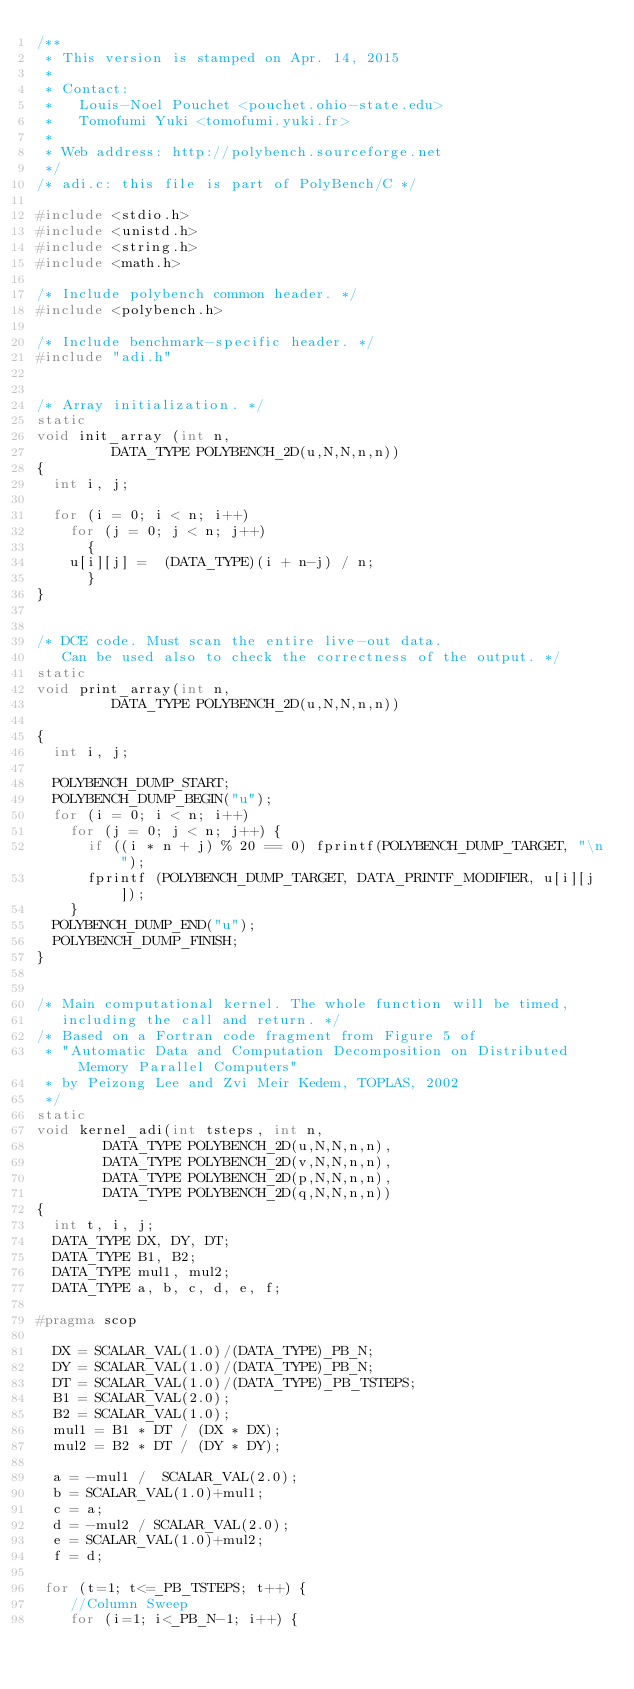Convert code to text. <code><loc_0><loc_0><loc_500><loc_500><_C_>/**
 * This version is stamped on Apr. 14, 2015
 *
 * Contact:
 *   Louis-Noel Pouchet <pouchet.ohio-state.edu>
 *   Tomofumi Yuki <tomofumi.yuki.fr>
 *
 * Web address: http://polybench.sourceforge.net
 */
/* adi.c: this file is part of PolyBench/C */

#include <stdio.h>
#include <unistd.h>
#include <string.h>
#include <math.h>

/* Include polybench common header. */
#include <polybench.h>

/* Include benchmark-specific header. */
#include "adi.h"


/* Array initialization. */
static
void init_array (int n,
		 DATA_TYPE POLYBENCH_2D(u,N,N,n,n))
{
  int i, j;

  for (i = 0; i < n; i++)
    for (j = 0; j < n; j++)
      {
	u[i][j] =  (DATA_TYPE)(i + n-j) / n;
      }
}


/* DCE code. Must scan the entire live-out data.
   Can be used also to check the correctness of the output. */
static
void print_array(int n,
		 DATA_TYPE POLYBENCH_2D(u,N,N,n,n))

{
  int i, j;

  POLYBENCH_DUMP_START;
  POLYBENCH_DUMP_BEGIN("u");
  for (i = 0; i < n; i++)
    for (j = 0; j < n; j++) {
      if ((i * n + j) % 20 == 0) fprintf(POLYBENCH_DUMP_TARGET, "\n");
      fprintf (POLYBENCH_DUMP_TARGET, DATA_PRINTF_MODIFIER, u[i][j]);
    }
  POLYBENCH_DUMP_END("u");
  POLYBENCH_DUMP_FINISH;
}


/* Main computational kernel. The whole function will be timed,
   including the call and return. */
/* Based on a Fortran code fragment from Figure 5 of
 * "Automatic Data and Computation Decomposition on Distributed Memory Parallel Computers"
 * by Peizong Lee and Zvi Meir Kedem, TOPLAS, 2002
 */
static
void kernel_adi(int tsteps, int n,
		DATA_TYPE POLYBENCH_2D(u,N,N,n,n),
		DATA_TYPE POLYBENCH_2D(v,N,N,n,n),
		DATA_TYPE POLYBENCH_2D(p,N,N,n,n),
		DATA_TYPE POLYBENCH_2D(q,N,N,n,n))
{
  int t, i, j;
  DATA_TYPE DX, DY, DT;
  DATA_TYPE B1, B2;
  DATA_TYPE mul1, mul2;
  DATA_TYPE a, b, c, d, e, f;

#pragma scop

  DX = SCALAR_VAL(1.0)/(DATA_TYPE)_PB_N;
  DY = SCALAR_VAL(1.0)/(DATA_TYPE)_PB_N;
  DT = SCALAR_VAL(1.0)/(DATA_TYPE)_PB_TSTEPS;
  B1 = SCALAR_VAL(2.0);
  B2 = SCALAR_VAL(1.0);
  mul1 = B1 * DT / (DX * DX);
  mul2 = B2 * DT / (DY * DY);

  a = -mul1 /  SCALAR_VAL(2.0);
  b = SCALAR_VAL(1.0)+mul1;
  c = a;
  d = -mul2 / SCALAR_VAL(2.0);
  e = SCALAR_VAL(1.0)+mul2;
  f = d;

 for (t=1; t<=_PB_TSTEPS; t++) {
    //Column Sweep
    for (i=1; i<_PB_N-1; i++) {</code> 